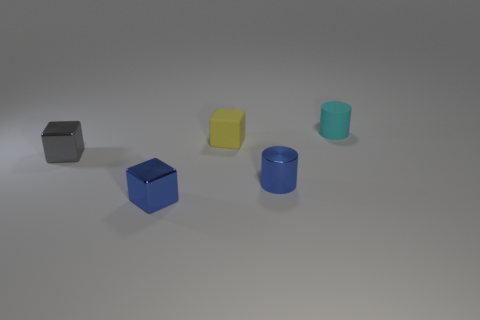Subtract all blue cubes. How many cubes are left? 2 Add 4 big cyan metal cylinders. How many objects exist? 9 Subtract all cylinders. How many objects are left? 3 Subtract all gray cylinders. Subtract all gray balls. How many cylinders are left? 2 Subtract all brown cubes. How many yellow cylinders are left? 0 Subtract all tiny brown metal objects. Subtract all yellow matte blocks. How many objects are left? 4 Add 2 cyan objects. How many cyan objects are left? 3 Add 2 small blue shiny blocks. How many small blue shiny blocks exist? 3 Subtract all cyan cylinders. How many cylinders are left? 1 Subtract 0 brown cubes. How many objects are left? 5 